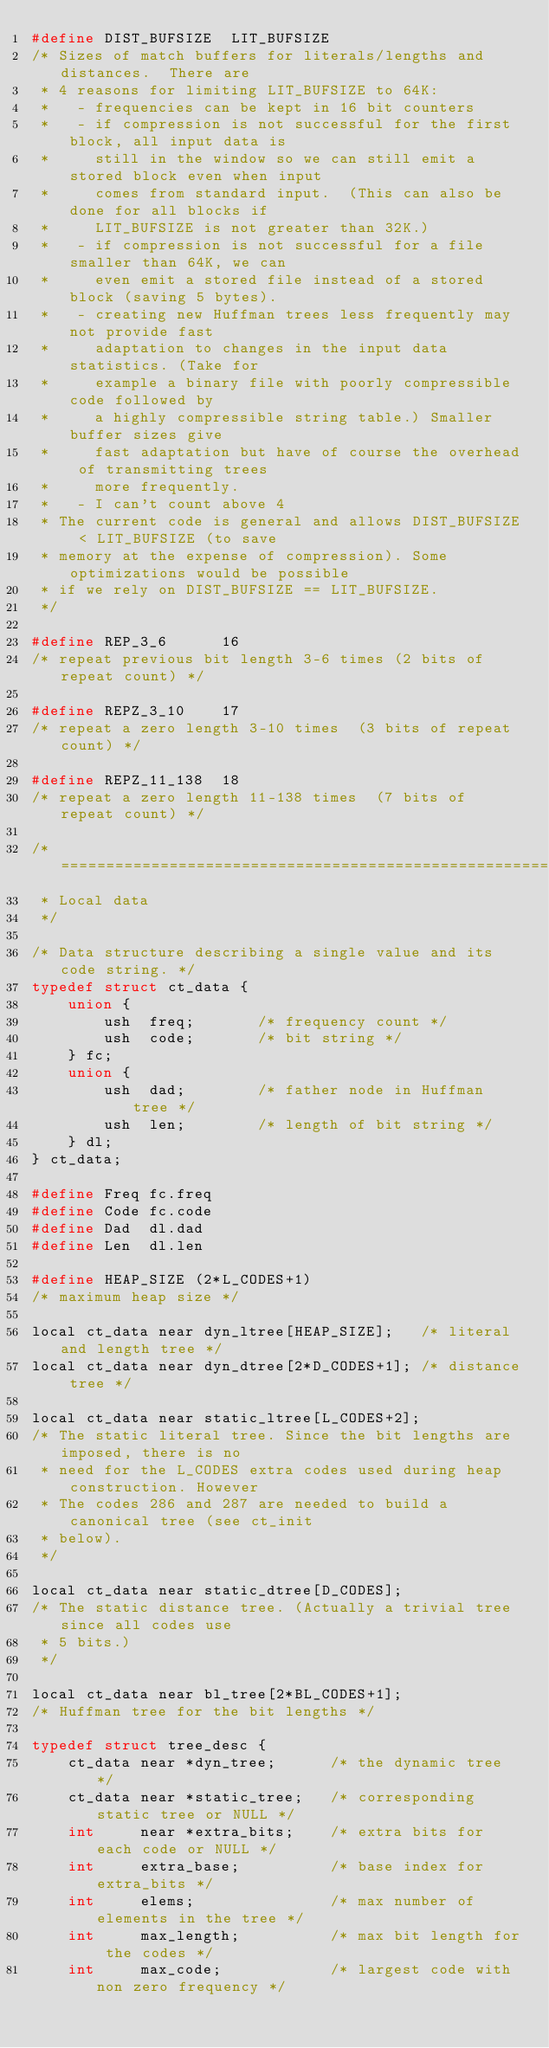<code> <loc_0><loc_0><loc_500><loc_500><_C_>#define DIST_BUFSIZE  LIT_BUFSIZE
/* Sizes of match buffers for literals/lengths and distances.  There are
 * 4 reasons for limiting LIT_BUFSIZE to 64K:
 *   - frequencies can be kept in 16 bit counters
 *   - if compression is not successful for the first block, all input data is
 *     still in the window so we can still emit a stored block even when input
 *     comes from standard input.  (This can also be done for all blocks if
 *     LIT_BUFSIZE is not greater than 32K.)
 *   - if compression is not successful for a file smaller than 64K, we can
 *     even emit a stored file instead of a stored block (saving 5 bytes).
 *   - creating new Huffman trees less frequently may not provide fast
 *     adaptation to changes in the input data statistics. (Take for
 *     example a binary file with poorly compressible code followed by
 *     a highly compressible string table.) Smaller buffer sizes give
 *     fast adaptation but have of course the overhead of transmitting trees
 *     more frequently.
 *   - I can't count above 4
 * The current code is general and allows DIST_BUFSIZE < LIT_BUFSIZE (to save
 * memory at the expense of compression). Some optimizations would be possible
 * if we rely on DIST_BUFSIZE == LIT_BUFSIZE.
 */

#define REP_3_6      16
/* repeat previous bit length 3-6 times (2 bits of repeat count) */

#define REPZ_3_10    17
/* repeat a zero length 3-10 times  (3 bits of repeat count) */

#define REPZ_11_138  18
/* repeat a zero length 11-138 times  (7 bits of repeat count) */

/* ===========================================================================
 * Local data
 */

/* Data structure describing a single value and its code string. */
typedef struct ct_data {
    union {
        ush  freq;       /* frequency count */
        ush  code;       /* bit string */
    } fc;
    union {
        ush  dad;        /* father node in Huffman tree */
        ush  len;        /* length of bit string */
    } dl;
} ct_data;

#define Freq fc.freq
#define Code fc.code
#define Dad  dl.dad
#define Len  dl.len

#define HEAP_SIZE (2*L_CODES+1)
/* maximum heap size */

local ct_data near dyn_ltree[HEAP_SIZE];   /* literal and length tree */
local ct_data near dyn_dtree[2*D_CODES+1]; /* distance tree */

local ct_data near static_ltree[L_CODES+2];
/* The static literal tree. Since the bit lengths are imposed, there is no
 * need for the L_CODES extra codes used during heap construction. However
 * The codes 286 and 287 are needed to build a canonical tree (see ct_init
 * below).
 */

local ct_data near static_dtree[D_CODES];
/* The static distance tree. (Actually a trivial tree since all codes use
 * 5 bits.)
 */

local ct_data near bl_tree[2*BL_CODES+1];
/* Huffman tree for the bit lengths */

typedef struct tree_desc {
    ct_data near *dyn_tree;      /* the dynamic tree */
    ct_data near *static_tree;   /* corresponding static tree or NULL */
    int     near *extra_bits;    /* extra bits for each code or NULL */
    int     extra_base;          /* base index for extra_bits */
    int     elems;               /* max number of elements in the tree */
    int     max_length;          /* max bit length for the codes */
    int     max_code;            /* largest code with non zero frequency */</code> 